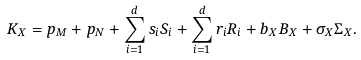<formula> <loc_0><loc_0><loc_500><loc_500>K _ { X } = p _ { M } + p _ { N } + \sum _ { i = 1 } ^ { d } s _ { i } S _ { i } + \sum _ { i = 1 } ^ { d } r _ { i } R _ { i } + b _ { X } B _ { X } + \sigma _ { X } \Sigma _ { X } .</formula> 